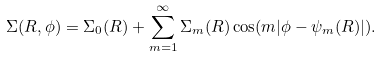Convert formula to latex. <formula><loc_0><loc_0><loc_500><loc_500>\Sigma ( R , \phi ) = \Sigma _ { 0 } ( R ) + \sum _ { m = 1 } ^ { \infty } \Sigma _ { m } ( R ) \cos ( m | \phi - \psi _ { m } ( R ) | ) .</formula> 